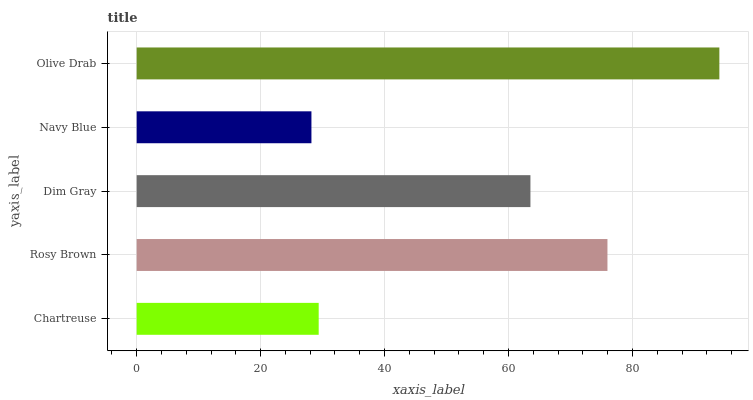Is Navy Blue the minimum?
Answer yes or no. Yes. Is Olive Drab the maximum?
Answer yes or no. Yes. Is Rosy Brown the minimum?
Answer yes or no. No. Is Rosy Brown the maximum?
Answer yes or no. No. Is Rosy Brown greater than Chartreuse?
Answer yes or no. Yes. Is Chartreuse less than Rosy Brown?
Answer yes or no. Yes. Is Chartreuse greater than Rosy Brown?
Answer yes or no. No. Is Rosy Brown less than Chartreuse?
Answer yes or no. No. Is Dim Gray the high median?
Answer yes or no. Yes. Is Dim Gray the low median?
Answer yes or no. Yes. Is Rosy Brown the high median?
Answer yes or no. No. Is Navy Blue the low median?
Answer yes or no. No. 